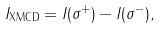<formula> <loc_0><loc_0><loc_500><loc_500>I _ { \text {XMCD} } = I ( \sigma ^ { + } ) - I ( \sigma ^ { - } ) ,</formula> 